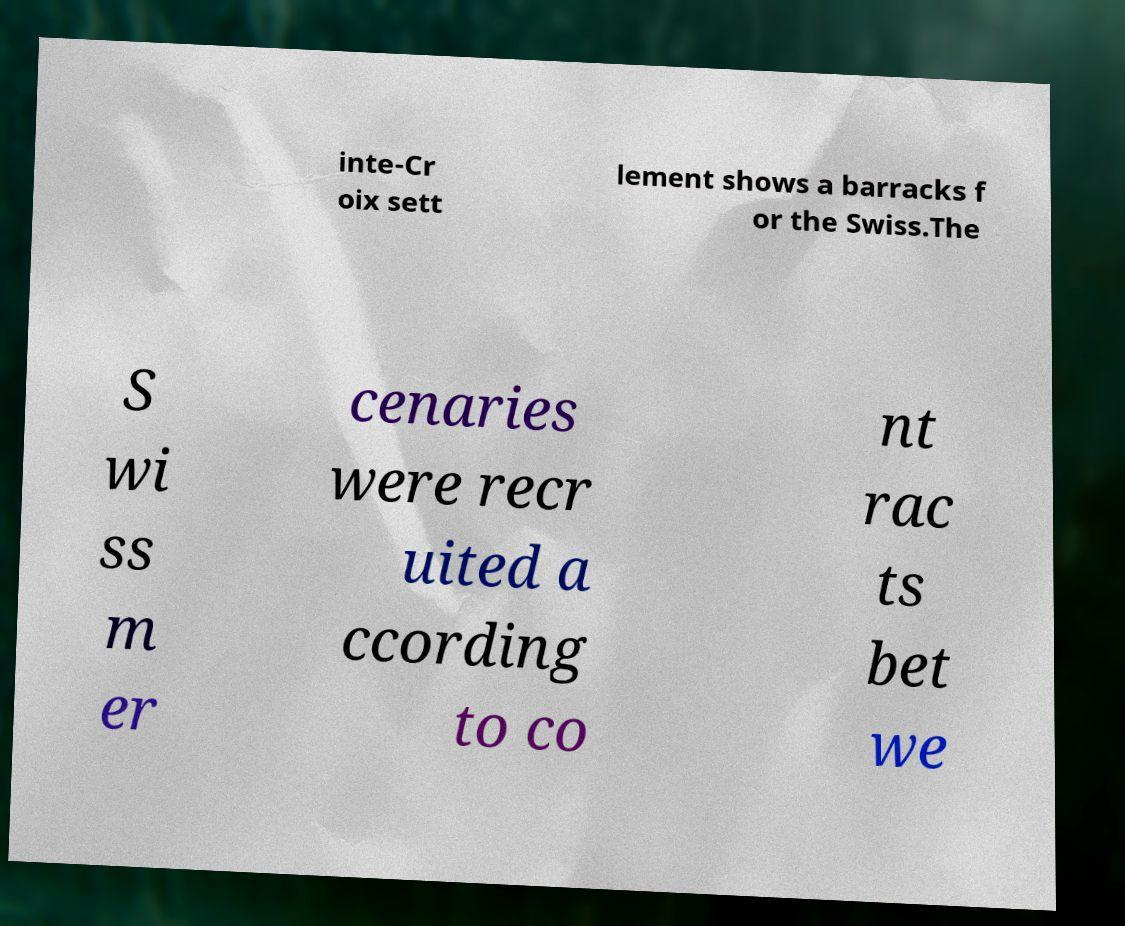Can you read and provide the text displayed in the image?This photo seems to have some interesting text. Can you extract and type it out for me? inte-Cr oix sett lement shows a barracks f or the Swiss.The S wi ss m er cenaries were recr uited a ccording to co nt rac ts bet we 